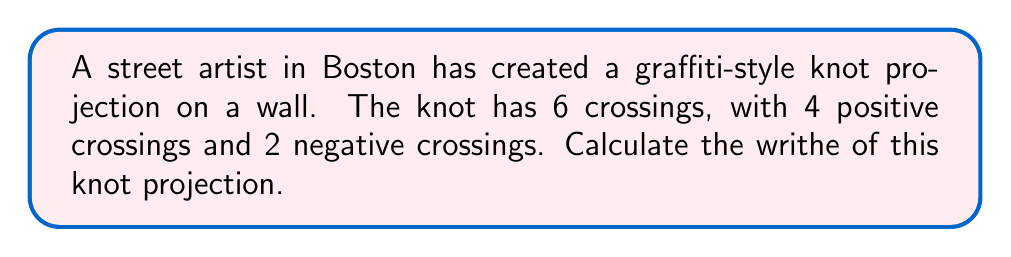Provide a solution to this math problem. To calculate the writhe of a knot projection, we follow these steps:

1. Understand the concept of writhe:
   The writhe is a measure of the extent to which a knot diagram is "knotted" or "twisted". It is calculated by summing the signs of all crossings in the knot projection.

2. Identify the crossings:
   In this case, we have 6 crossings total.

3. Determine the sign of each crossing:
   - Positive crossings: 4
   - Negative crossings: 2

4. Calculate the writhe:
   The writhe is calculated using the formula:
   $$\text{Writhe} = \sum_{i=1}^{n} \text{sign}(c_i)$$
   where $n$ is the total number of crossings and $c_i$ is the $i$-th crossing.

5. Apply the formula:
   $$\text{Writhe} = (+1) \times 4 + (-1) \times 2$$

6. Perform the calculation:
   $$\text{Writhe} = 4 - 2 = 2$$

Therefore, the writhe of the graffiti-style knot projection is 2.
Answer: 2 